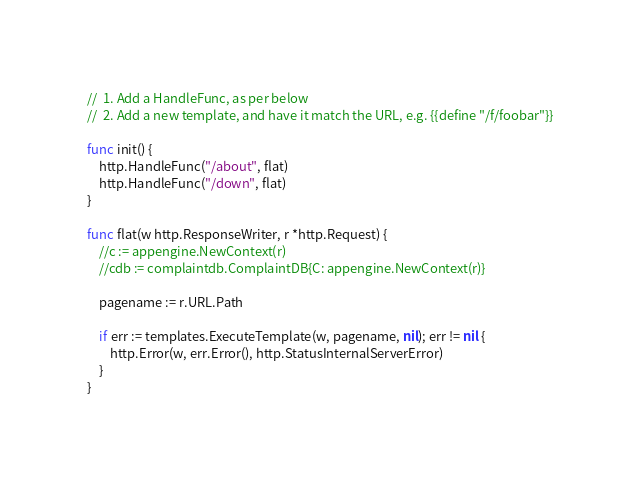Convert code to text. <code><loc_0><loc_0><loc_500><loc_500><_Go_>//  1. Add a HandleFunc, as per below
//  2. Add a new template, and have it match the URL, e.g. {{define "/f/foobar"}}

func init() {
	http.HandleFunc("/about", flat)
	http.HandleFunc("/down", flat)
}

func flat(w http.ResponseWriter, r *http.Request) {
	//c := appengine.NewContext(r)
	//cdb := complaintdb.ComplaintDB{C: appengine.NewContext(r)}

	pagename := r.URL.Path

	if err := templates.ExecuteTemplate(w, pagename, nil); err != nil {
		http.Error(w, err.Error(), http.StatusInternalServerError)
	}
}
</code> 